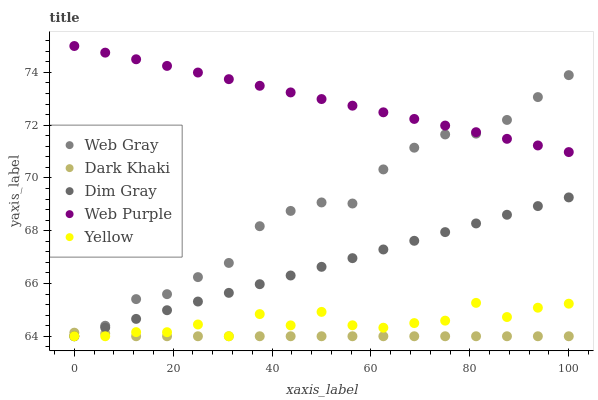Does Dark Khaki have the minimum area under the curve?
Answer yes or no. Yes. Does Web Purple have the maximum area under the curve?
Answer yes or no. Yes. Does Dim Gray have the minimum area under the curve?
Answer yes or no. No. Does Dim Gray have the maximum area under the curve?
Answer yes or no. No. Is Dim Gray the smoothest?
Answer yes or no. Yes. Is Yellow the roughest?
Answer yes or no. Yes. Is Web Gray the smoothest?
Answer yes or no. No. Is Web Gray the roughest?
Answer yes or no. No. Does Dark Khaki have the lowest value?
Answer yes or no. Yes. Does Web Purple have the lowest value?
Answer yes or no. No. Does Web Purple have the highest value?
Answer yes or no. Yes. Does Dim Gray have the highest value?
Answer yes or no. No. Is Dark Khaki less than Web Purple?
Answer yes or no. Yes. Is Web Purple greater than Dim Gray?
Answer yes or no. Yes. Does Web Gray intersect Web Purple?
Answer yes or no. Yes. Is Web Gray less than Web Purple?
Answer yes or no. No. Is Web Gray greater than Web Purple?
Answer yes or no. No. Does Dark Khaki intersect Web Purple?
Answer yes or no. No. 